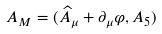Convert formula to latex. <formula><loc_0><loc_0><loc_500><loc_500>A _ { M } = ( \widehat { A } _ { \mu } + \partial _ { \mu } \varphi , A _ { 5 } )</formula> 